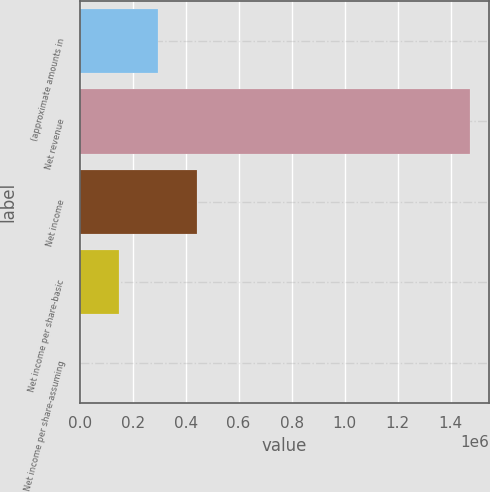Convert chart to OTSL. <chart><loc_0><loc_0><loc_500><loc_500><bar_chart><fcel>(approximate amounts in<fcel>Net revenue<fcel>Net income<fcel>Net income per share-basic<fcel>Net income per share-assuming<nl><fcel>294480<fcel>1.4724e+06<fcel>441720<fcel>147240<fcel>0.5<nl></chart> 